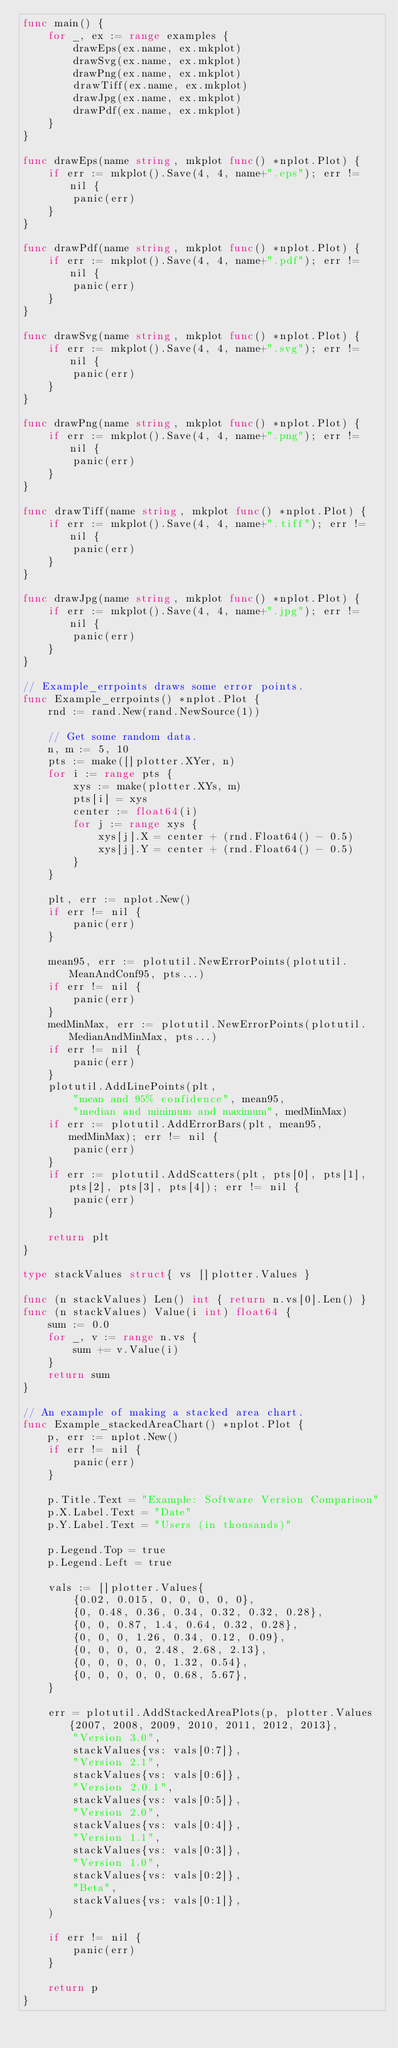<code> <loc_0><loc_0><loc_500><loc_500><_Go_>func main() {
	for _, ex := range examples {
		drawEps(ex.name, ex.mkplot)
		drawSvg(ex.name, ex.mkplot)
		drawPng(ex.name, ex.mkplot)
		drawTiff(ex.name, ex.mkplot)
		drawJpg(ex.name, ex.mkplot)
		drawPdf(ex.name, ex.mkplot)
	}
}

func drawEps(name string, mkplot func() *nplot.Plot) {
	if err := mkplot().Save(4, 4, name+".eps"); err != nil {
		panic(err)
	}
}

func drawPdf(name string, mkplot func() *nplot.Plot) {
	if err := mkplot().Save(4, 4, name+".pdf"); err != nil {
		panic(err)
	}
}

func drawSvg(name string, mkplot func() *nplot.Plot) {
	if err := mkplot().Save(4, 4, name+".svg"); err != nil {
		panic(err)
	}
}

func drawPng(name string, mkplot func() *nplot.Plot) {
	if err := mkplot().Save(4, 4, name+".png"); err != nil {
		panic(err)
	}
}

func drawTiff(name string, mkplot func() *nplot.Plot) {
	if err := mkplot().Save(4, 4, name+".tiff"); err != nil {
		panic(err)
	}
}

func drawJpg(name string, mkplot func() *nplot.Plot) {
	if err := mkplot().Save(4, 4, name+".jpg"); err != nil {
		panic(err)
	}
}

// Example_errpoints draws some error points.
func Example_errpoints() *nplot.Plot {
	rnd := rand.New(rand.NewSource(1))

	// Get some random data.
	n, m := 5, 10
	pts := make([]plotter.XYer, n)
	for i := range pts {
		xys := make(plotter.XYs, m)
		pts[i] = xys
		center := float64(i)
		for j := range xys {
			xys[j].X = center + (rnd.Float64() - 0.5)
			xys[j].Y = center + (rnd.Float64() - 0.5)
		}
	}

	plt, err := nplot.New()
	if err != nil {
		panic(err)
	}

	mean95, err := plotutil.NewErrorPoints(plotutil.MeanAndConf95, pts...)
	if err != nil {
		panic(err)
	}
	medMinMax, err := plotutil.NewErrorPoints(plotutil.MedianAndMinMax, pts...)
	if err != nil {
		panic(err)
	}
	plotutil.AddLinePoints(plt,
		"mean and 95% confidence", mean95,
		"median and minimum and maximum", medMinMax)
	if err := plotutil.AddErrorBars(plt, mean95, medMinMax); err != nil {
		panic(err)
	}
	if err := plotutil.AddScatters(plt, pts[0], pts[1], pts[2], pts[3], pts[4]); err != nil {
		panic(err)
	}

	return plt
}

type stackValues struct{ vs []plotter.Values }

func (n stackValues) Len() int { return n.vs[0].Len() }
func (n stackValues) Value(i int) float64 {
	sum := 0.0
	for _, v := range n.vs {
		sum += v.Value(i)
	}
	return sum
}

// An example of making a stacked area chart.
func Example_stackedAreaChart() *nplot.Plot {
	p, err := nplot.New()
	if err != nil {
		panic(err)
	}

	p.Title.Text = "Example: Software Version Comparison"
	p.X.Label.Text = "Date"
	p.Y.Label.Text = "Users (in thousands)"

	p.Legend.Top = true
	p.Legend.Left = true

	vals := []plotter.Values{
		{0.02, 0.015, 0, 0, 0, 0, 0},
		{0, 0.48, 0.36, 0.34, 0.32, 0.32, 0.28},
		{0, 0, 0.87, 1.4, 0.64, 0.32, 0.28},
		{0, 0, 0, 1.26, 0.34, 0.12, 0.09},
		{0, 0, 0, 0, 2.48, 2.68, 2.13},
		{0, 0, 0, 0, 0, 1.32, 0.54},
		{0, 0, 0, 0, 0, 0.68, 5.67},
	}

	err = plotutil.AddStackedAreaPlots(p, plotter.Values{2007, 2008, 2009, 2010, 2011, 2012, 2013},
		"Version 3.0",
		stackValues{vs: vals[0:7]},
		"Version 2.1",
		stackValues{vs: vals[0:6]},
		"Version 2.0.1",
		stackValues{vs: vals[0:5]},
		"Version 2.0",
		stackValues{vs: vals[0:4]},
		"Version 1.1",
		stackValues{vs: vals[0:3]},
		"Version 1.0",
		stackValues{vs: vals[0:2]},
		"Beta",
		stackValues{vs: vals[0:1]},
	)

	if err != nil {
		panic(err)
	}

	return p
}
</code> 